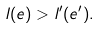<formula> <loc_0><loc_0><loc_500><loc_500>l ( e ) > l ^ { \prime } ( e ^ { \prime } ) .</formula> 